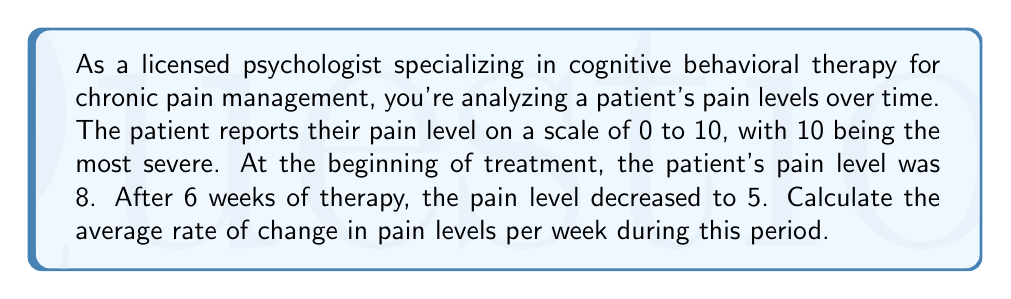Can you solve this math problem? To calculate the average rate of change in pain levels per week, we need to use the slope formula:

$$ \text{Rate of change} = \frac{\text{Change in y}}{\text{Change in x}} = \frac{y_2 - y_1}{x_2 - x_1} $$

Where:
- $y_2$ is the final pain level
- $y_1$ is the initial pain level
- $x_2$ is the final time (in weeks)
- $x_1$ is the initial time (in weeks)

Let's plug in the values:
- Initial pain level ($y_1$) = 8
- Final pain level ($y_2$) = 5
- Initial time ($x_1$) = 0 weeks
- Final time ($x_2$) = 6 weeks

$$ \text{Rate of change} = \frac{5 - 8}{6 - 0} = \frac{-3}{6} = -0.5 $$

The negative sign indicates a decrease in pain levels.
Answer: $-0.5$ pain units per week 